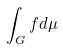Convert formula to latex. <formula><loc_0><loc_0><loc_500><loc_500>\int _ { G } f d \mu</formula> 